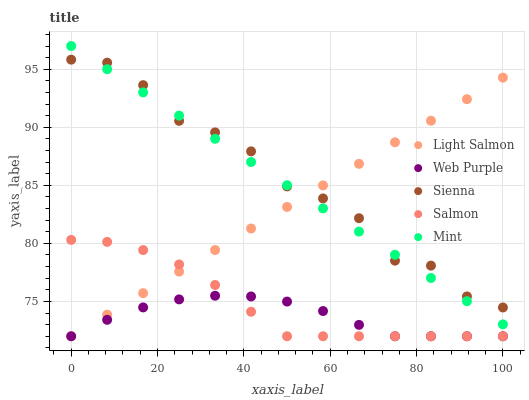Does Web Purple have the minimum area under the curve?
Answer yes or no. Yes. Does Sienna have the maximum area under the curve?
Answer yes or no. Yes. Does Mint have the minimum area under the curve?
Answer yes or no. No. Does Mint have the maximum area under the curve?
Answer yes or no. No. Is Mint the smoothest?
Answer yes or no. Yes. Is Sienna the roughest?
Answer yes or no. Yes. Is Light Salmon the smoothest?
Answer yes or no. No. Is Light Salmon the roughest?
Answer yes or no. No. Does Light Salmon have the lowest value?
Answer yes or no. Yes. Does Mint have the lowest value?
Answer yes or no. No. Does Mint have the highest value?
Answer yes or no. Yes. Does Light Salmon have the highest value?
Answer yes or no. No. Is Salmon less than Sienna?
Answer yes or no. Yes. Is Sienna greater than Web Purple?
Answer yes or no. Yes. Does Light Salmon intersect Mint?
Answer yes or no. Yes. Is Light Salmon less than Mint?
Answer yes or no. No. Is Light Salmon greater than Mint?
Answer yes or no. No. Does Salmon intersect Sienna?
Answer yes or no. No. 